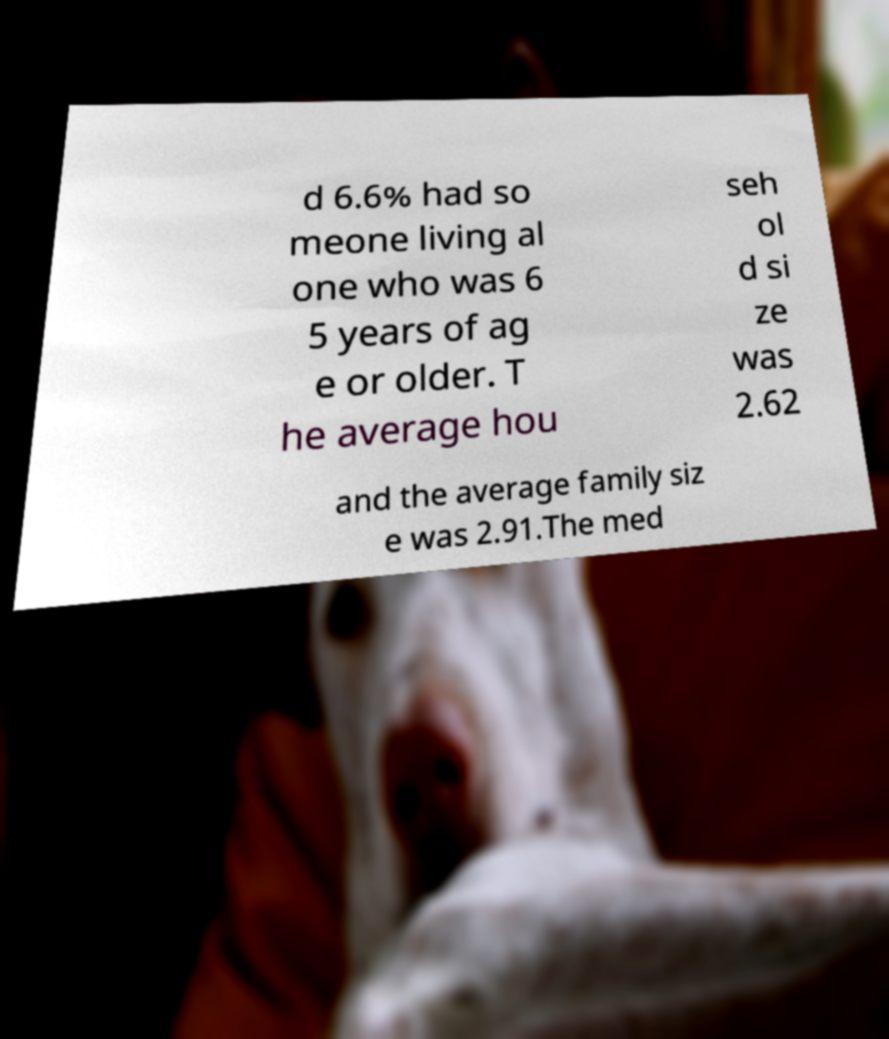Please identify and transcribe the text found in this image. d 6.6% had so meone living al one who was 6 5 years of ag e or older. T he average hou seh ol d si ze was 2.62 and the average family siz e was 2.91.The med 